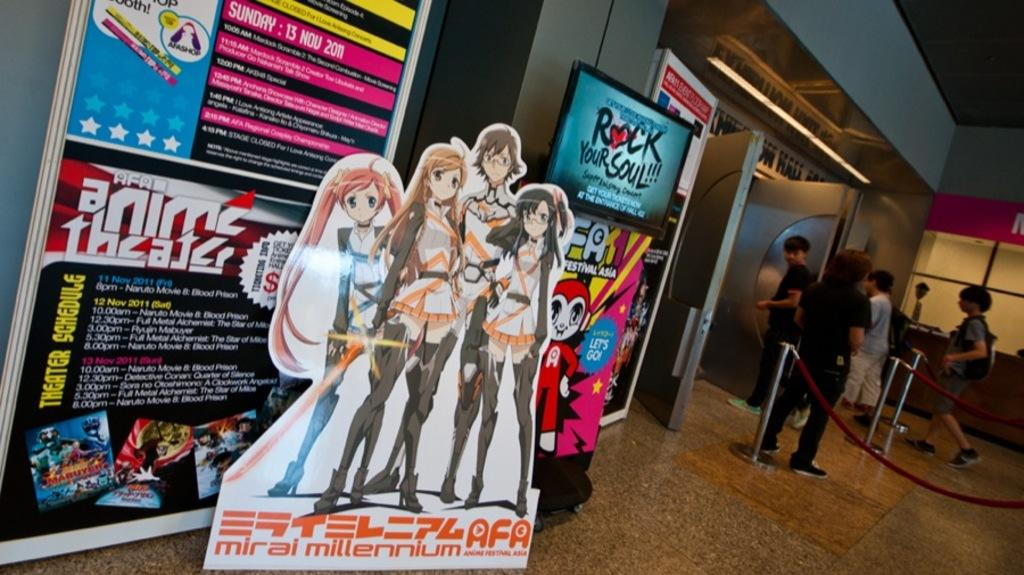<image>
Summarize the visual content of the image. A line area and cardboard cutouts for anime theater. 